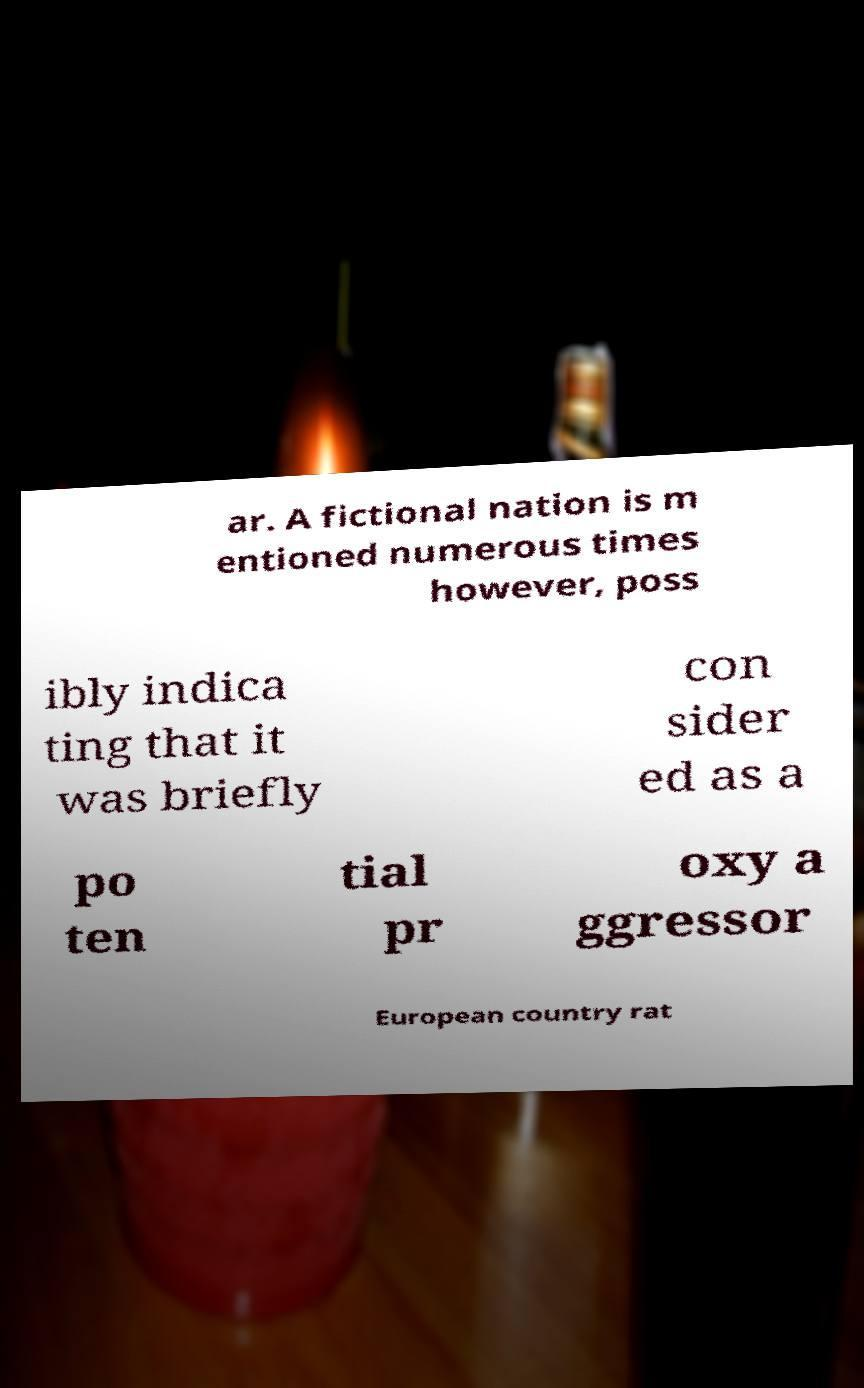Please read and relay the text visible in this image. What does it say? ar. A fictional nation is m entioned numerous times however, poss ibly indica ting that it was briefly con sider ed as a po ten tial pr oxy a ggressor European country rat 